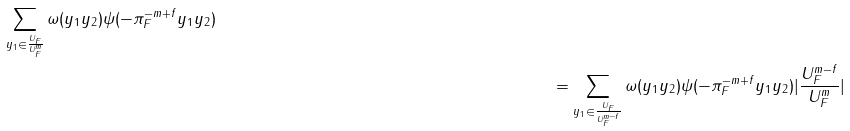<formula> <loc_0><loc_0><loc_500><loc_500>{ \sum _ { y _ { 1 } \in \frac { U _ { F } } { U _ { F } ^ { m } } } \omega ( y _ { 1 } y _ { 2 } ) \psi ( - \pi _ { F } ^ { - m + f } y _ { 1 } y _ { 2 } ) } & & \\ & & = \sum _ { y _ { 1 } \in \frac { U _ { F } } { U _ { F } ^ { m - f } } } \omega ( y _ { 1 } y _ { 2 } ) \psi ( - \pi _ { F } ^ { - m + f } y _ { 1 } y _ { 2 } ) | \frac { U _ { F } ^ { m - f } } { U _ { F } ^ { m } } |</formula> 